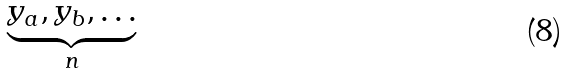Convert formula to latex. <formula><loc_0><loc_0><loc_500><loc_500>\underbrace { y _ { a } , y _ { b } , \dots } _ { n }</formula> 